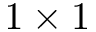<formula> <loc_0><loc_0><loc_500><loc_500>1 \times 1</formula> 